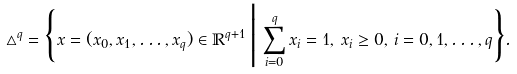<formula> <loc_0><loc_0><loc_500><loc_500>\triangle ^ { q } = \Big \{ x = ( x _ { 0 } , x _ { 1 } , \dots , x _ { q } ) \in \mathbb { R } ^ { q + 1 } \, \Big | \, \sum _ { i = 0 } ^ { q } x _ { i } = 1 , \, x _ { i } \geq 0 , \, i = 0 , 1 , \dots , q \Big \} .</formula> 